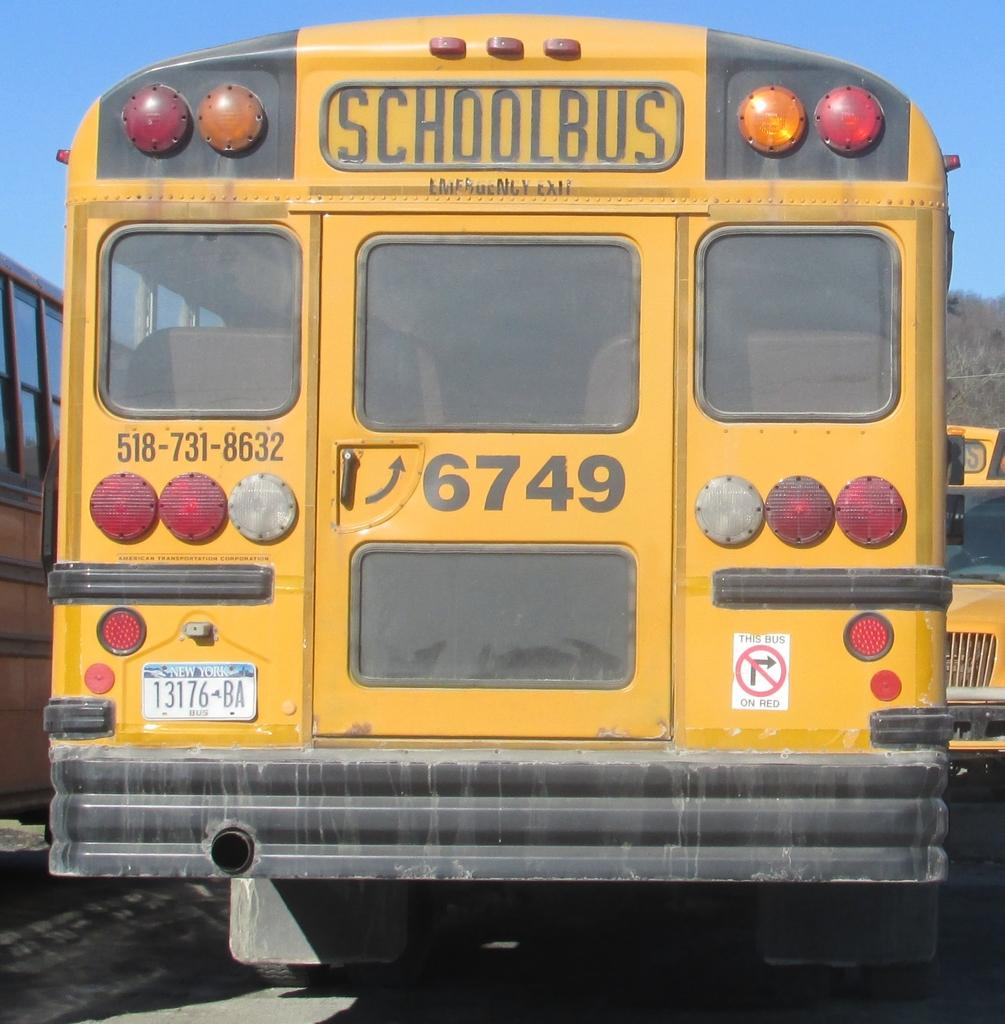<image>
Provide a brief description of the given image. A yellow school bus with the numbers 6749 on its back door. 